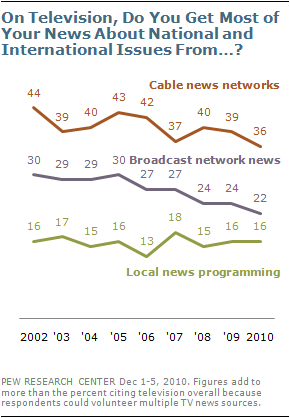Point out several critical features in this image. The Green segment in the graph represents local news programming. The number of times the number 16 appears in local news programming is four. 